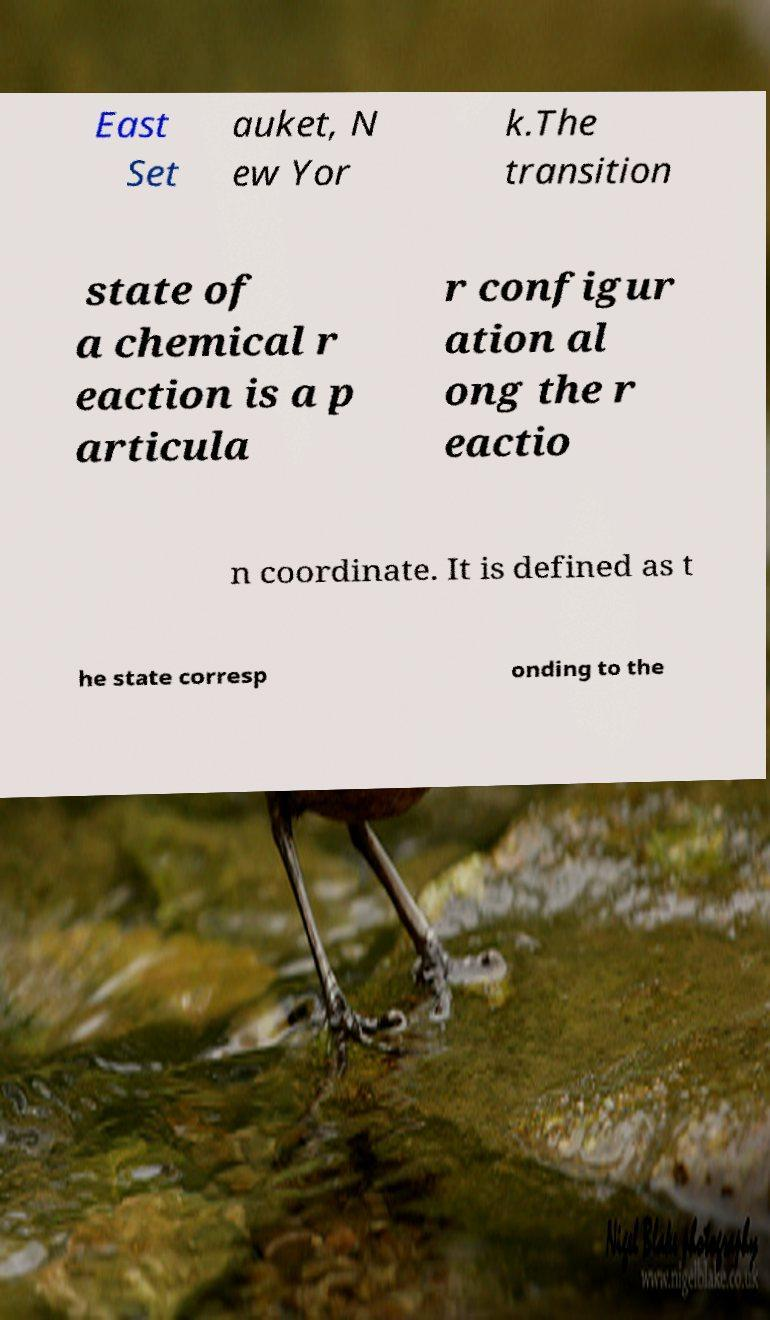Can you accurately transcribe the text from the provided image for me? East Set auket, N ew Yor k.The transition state of a chemical r eaction is a p articula r configur ation al ong the r eactio n coordinate. It is defined as t he state corresp onding to the 